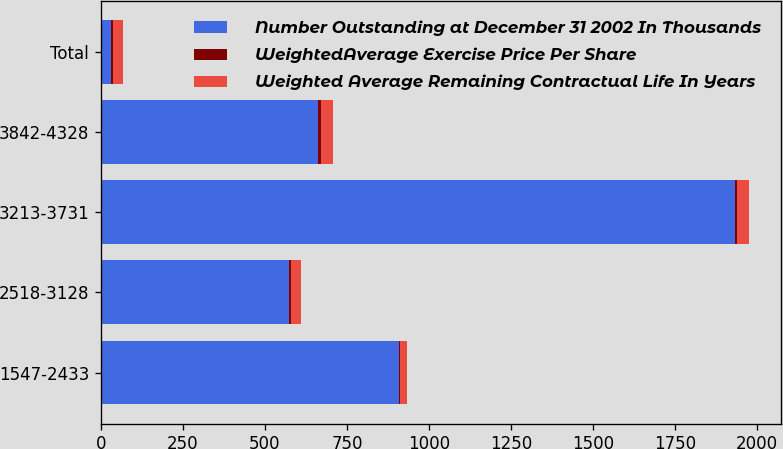<chart> <loc_0><loc_0><loc_500><loc_500><stacked_bar_chart><ecel><fcel>1547-2433<fcel>2518-3128<fcel>3213-3731<fcel>3842-4328<fcel>Total<nl><fcel>Number Outstanding at December 31 2002 In Thousands<fcel>909<fcel>574<fcel>1934<fcel>662<fcel>29.705<nl><fcel>WeightedAverage Exercise Price Per Share<fcel>3.2<fcel>6.8<fcel>6.4<fcel>8.1<fcel>6<nl><fcel>Weighted Average Remaining Contractual Life In Years<fcel>21.95<fcel>27.72<fcel>34.97<fcel>38.9<fcel>31.69<nl></chart> 